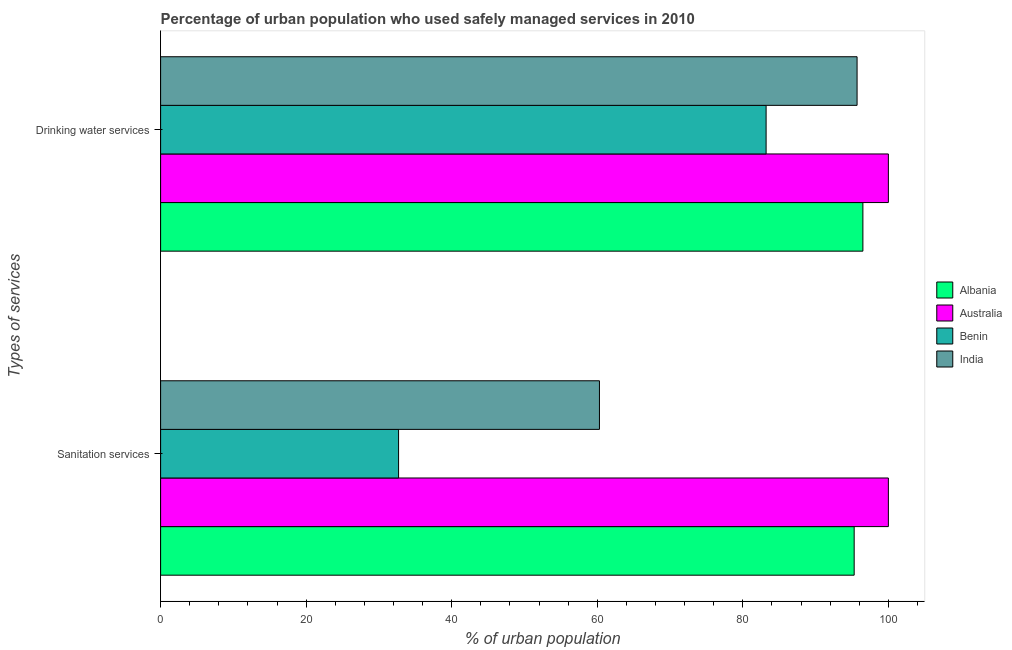How many different coloured bars are there?
Your response must be concise. 4. Are the number of bars on each tick of the Y-axis equal?
Your answer should be very brief. Yes. What is the label of the 2nd group of bars from the top?
Provide a short and direct response. Sanitation services. What is the percentage of urban population who used drinking water services in Benin?
Your answer should be compact. 83.2. Across all countries, what is the minimum percentage of urban population who used sanitation services?
Offer a very short reply. 32.7. In which country was the percentage of urban population who used drinking water services minimum?
Offer a terse response. Benin. What is the total percentage of urban population who used drinking water services in the graph?
Your answer should be very brief. 375.4. What is the difference between the percentage of urban population who used sanitation services in India and that in Australia?
Your answer should be very brief. -39.7. What is the difference between the percentage of urban population who used drinking water services in Albania and the percentage of urban population who used sanitation services in Benin?
Make the answer very short. 63.8. What is the average percentage of urban population who used sanitation services per country?
Give a very brief answer. 72.08. What is the difference between the percentage of urban population who used drinking water services and percentage of urban population who used sanitation services in Benin?
Your answer should be very brief. 50.5. What is the ratio of the percentage of urban population who used drinking water services in Albania to that in India?
Your response must be concise. 1.01. What does the 1st bar from the top in Sanitation services represents?
Offer a terse response. India. What does the 1st bar from the bottom in Sanitation services represents?
Your answer should be very brief. Albania. Are all the bars in the graph horizontal?
Offer a very short reply. Yes. What is the difference between two consecutive major ticks on the X-axis?
Your answer should be very brief. 20. Are the values on the major ticks of X-axis written in scientific E-notation?
Ensure brevity in your answer.  No. Does the graph contain any zero values?
Make the answer very short. No. How many legend labels are there?
Your answer should be very brief. 4. How are the legend labels stacked?
Your answer should be very brief. Vertical. What is the title of the graph?
Provide a short and direct response. Percentage of urban population who used safely managed services in 2010. Does "Belize" appear as one of the legend labels in the graph?
Offer a very short reply. No. What is the label or title of the X-axis?
Offer a terse response. % of urban population. What is the label or title of the Y-axis?
Make the answer very short. Types of services. What is the % of urban population in Albania in Sanitation services?
Your response must be concise. 95.3. What is the % of urban population in Benin in Sanitation services?
Provide a succinct answer. 32.7. What is the % of urban population in India in Sanitation services?
Offer a very short reply. 60.3. What is the % of urban population of Albania in Drinking water services?
Make the answer very short. 96.5. What is the % of urban population in Australia in Drinking water services?
Your answer should be very brief. 100. What is the % of urban population of Benin in Drinking water services?
Keep it short and to the point. 83.2. What is the % of urban population in India in Drinking water services?
Offer a terse response. 95.7. Across all Types of services, what is the maximum % of urban population of Albania?
Offer a terse response. 96.5. Across all Types of services, what is the maximum % of urban population in Australia?
Offer a terse response. 100. Across all Types of services, what is the maximum % of urban population of Benin?
Keep it short and to the point. 83.2. Across all Types of services, what is the maximum % of urban population in India?
Provide a succinct answer. 95.7. Across all Types of services, what is the minimum % of urban population in Albania?
Make the answer very short. 95.3. Across all Types of services, what is the minimum % of urban population of Benin?
Provide a short and direct response. 32.7. Across all Types of services, what is the minimum % of urban population of India?
Provide a short and direct response. 60.3. What is the total % of urban population of Albania in the graph?
Keep it short and to the point. 191.8. What is the total % of urban population of Australia in the graph?
Your answer should be compact. 200. What is the total % of urban population in Benin in the graph?
Give a very brief answer. 115.9. What is the total % of urban population of India in the graph?
Your answer should be very brief. 156. What is the difference between the % of urban population in Albania in Sanitation services and that in Drinking water services?
Keep it short and to the point. -1.2. What is the difference between the % of urban population in Benin in Sanitation services and that in Drinking water services?
Your answer should be very brief. -50.5. What is the difference between the % of urban population of India in Sanitation services and that in Drinking water services?
Your answer should be compact. -35.4. What is the difference between the % of urban population of Benin in Sanitation services and the % of urban population of India in Drinking water services?
Give a very brief answer. -63. What is the average % of urban population in Albania per Types of services?
Your answer should be compact. 95.9. What is the average % of urban population of Australia per Types of services?
Give a very brief answer. 100. What is the average % of urban population in Benin per Types of services?
Give a very brief answer. 57.95. What is the difference between the % of urban population of Albania and % of urban population of Australia in Sanitation services?
Give a very brief answer. -4.7. What is the difference between the % of urban population in Albania and % of urban population in Benin in Sanitation services?
Offer a terse response. 62.6. What is the difference between the % of urban population in Albania and % of urban population in India in Sanitation services?
Your answer should be compact. 35. What is the difference between the % of urban population of Australia and % of urban population of Benin in Sanitation services?
Give a very brief answer. 67.3. What is the difference between the % of urban population in Australia and % of urban population in India in Sanitation services?
Your answer should be very brief. 39.7. What is the difference between the % of urban population in Benin and % of urban population in India in Sanitation services?
Your answer should be very brief. -27.6. What is the difference between the % of urban population in Albania and % of urban population in India in Drinking water services?
Your answer should be compact. 0.8. What is the ratio of the % of urban population in Albania in Sanitation services to that in Drinking water services?
Keep it short and to the point. 0.99. What is the ratio of the % of urban population in Australia in Sanitation services to that in Drinking water services?
Your answer should be very brief. 1. What is the ratio of the % of urban population in Benin in Sanitation services to that in Drinking water services?
Your response must be concise. 0.39. What is the ratio of the % of urban population of India in Sanitation services to that in Drinking water services?
Your answer should be compact. 0.63. What is the difference between the highest and the second highest % of urban population of Albania?
Your response must be concise. 1.2. What is the difference between the highest and the second highest % of urban population of Australia?
Offer a very short reply. 0. What is the difference between the highest and the second highest % of urban population of Benin?
Your answer should be very brief. 50.5. What is the difference between the highest and the second highest % of urban population of India?
Give a very brief answer. 35.4. What is the difference between the highest and the lowest % of urban population of Albania?
Make the answer very short. 1.2. What is the difference between the highest and the lowest % of urban population of Benin?
Keep it short and to the point. 50.5. What is the difference between the highest and the lowest % of urban population in India?
Provide a succinct answer. 35.4. 